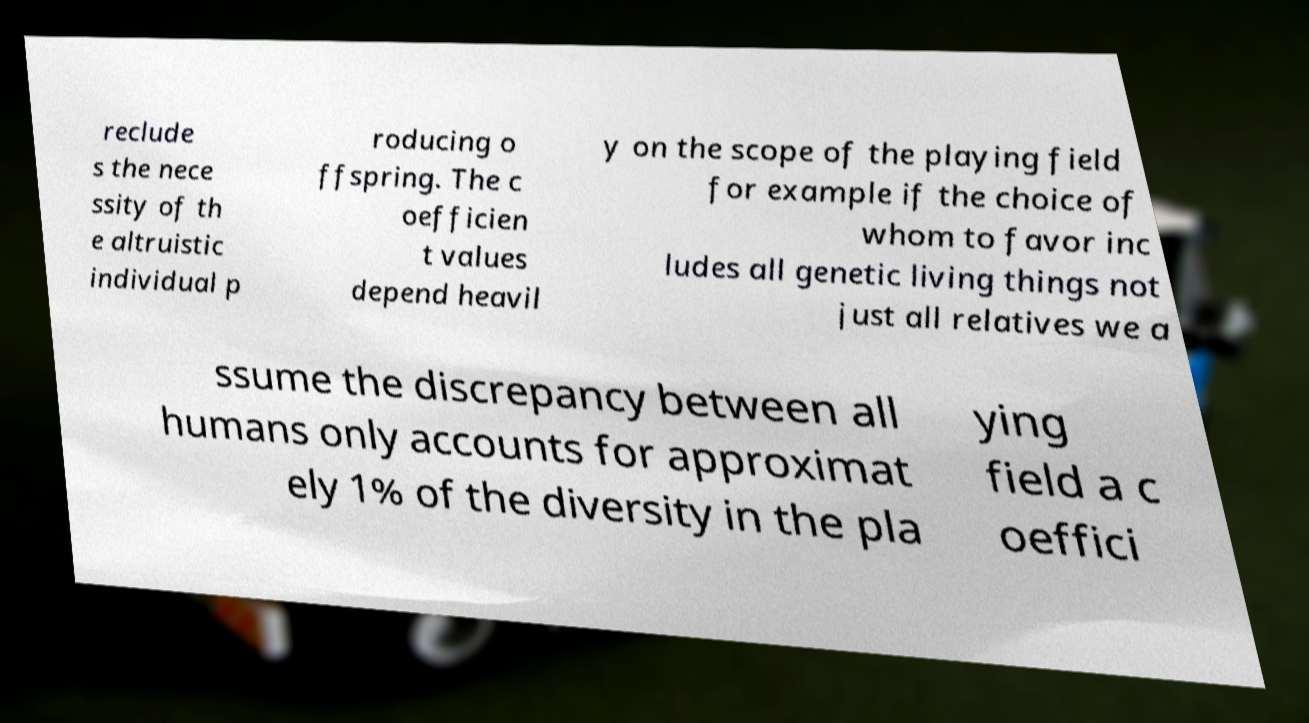Please read and relay the text visible in this image. What does it say? reclude s the nece ssity of th e altruistic individual p roducing o ffspring. The c oefficien t values depend heavil y on the scope of the playing field for example if the choice of whom to favor inc ludes all genetic living things not just all relatives we a ssume the discrepancy between all humans only accounts for approximat ely 1% of the diversity in the pla ying field a c oeffici 